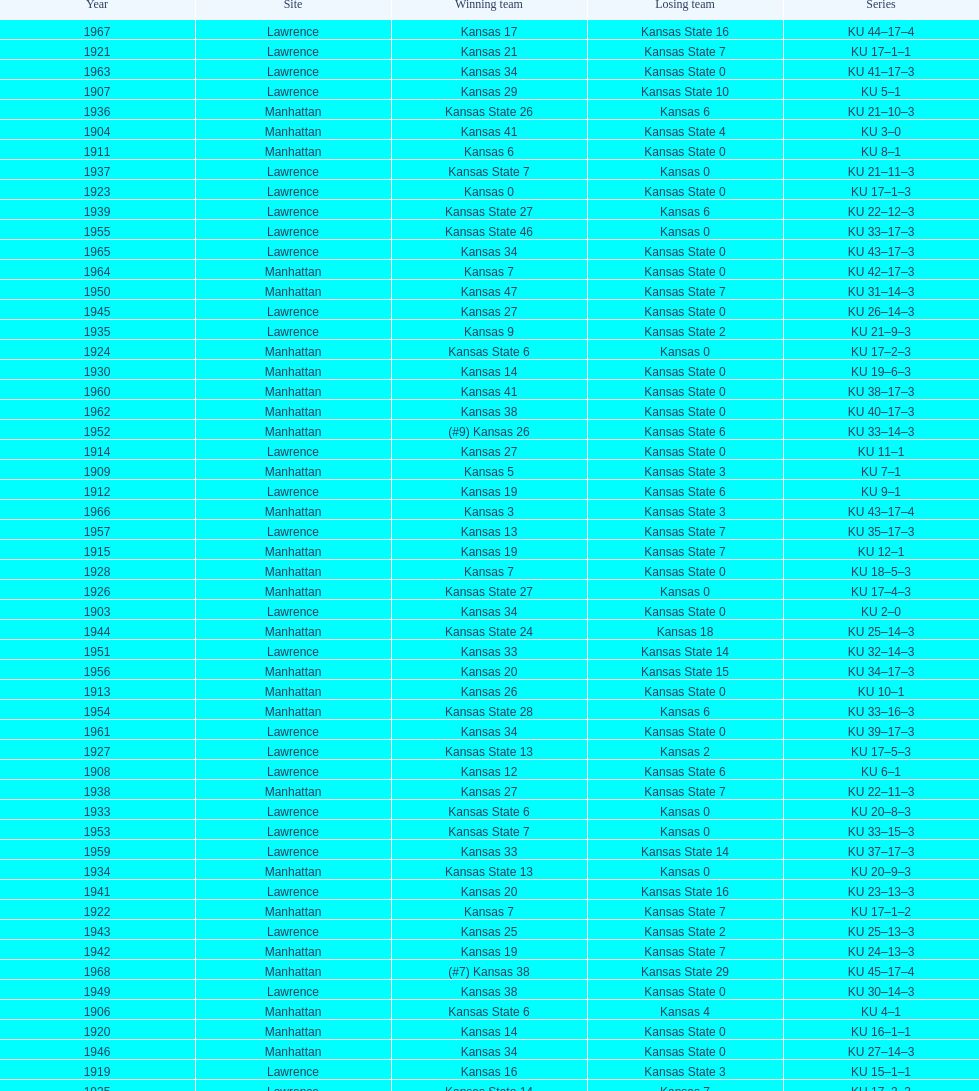What is the total number of games played? 66. 